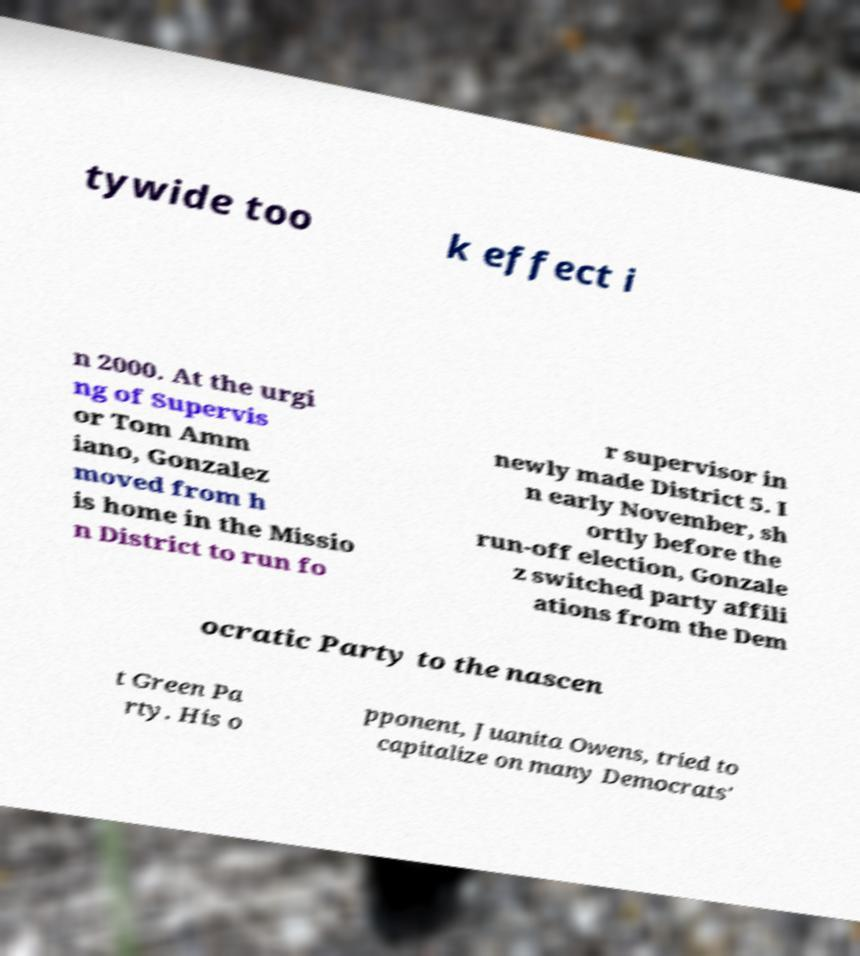Can you accurately transcribe the text from the provided image for me? tywide too k effect i n 2000. At the urgi ng of Supervis or Tom Amm iano, Gonzalez moved from h is home in the Missio n District to run fo r supervisor in newly made District 5. I n early November, sh ortly before the run-off election, Gonzale z switched party affili ations from the Dem ocratic Party to the nascen t Green Pa rty. His o pponent, Juanita Owens, tried to capitalize on many Democrats' 